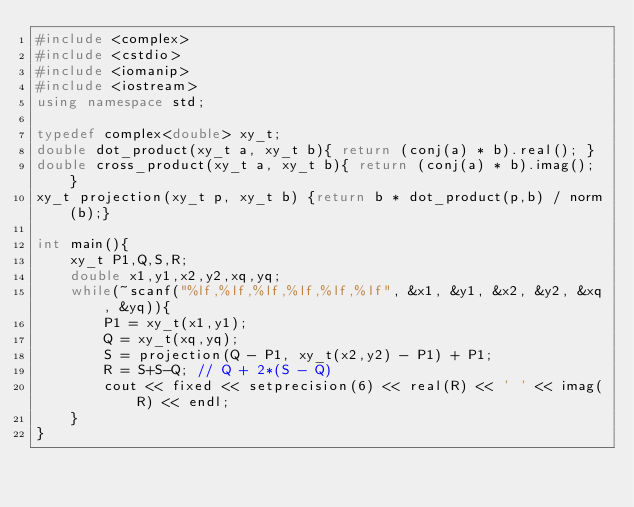Convert code to text. <code><loc_0><loc_0><loc_500><loc_500><_C++_>#include <complex>
#include <cstdio>
#include <iomanip>
#include <iostream>
using namespace std;

typedef complex<double> xy_t;
double dot_product(xy_t a, xy_t b){ return (conj(a) * b).real(); }
double cross_product(xy_t a, xy_t b){ return (conj(a) * b).imag(); }
xy_t projection(xy_t p, xy_t b) {return b * dot_product(p,b) / norm(b);}

int main(){
    xy_t P1,Q,S,R;
    double x1,y1,x2,y2,xq,yq;
    while(~scanf("%lf,%lf,%lf,%lf,%lf,%lf", &x1, &y1, &x2, &y2, &xq, &yq)){
        P1 = xy_t(x1,y1);
        Q = xy_t(xq,yq);
        S = projection(Q - P1, xy_t(x2,y2) - P1) + P1;
        R = S+S-Q; // Q + 2*(S - Q)
        cout << fixed << setprecision(6) << real(R) << ' ' << imag(R) << endl;
    }
}</code> 